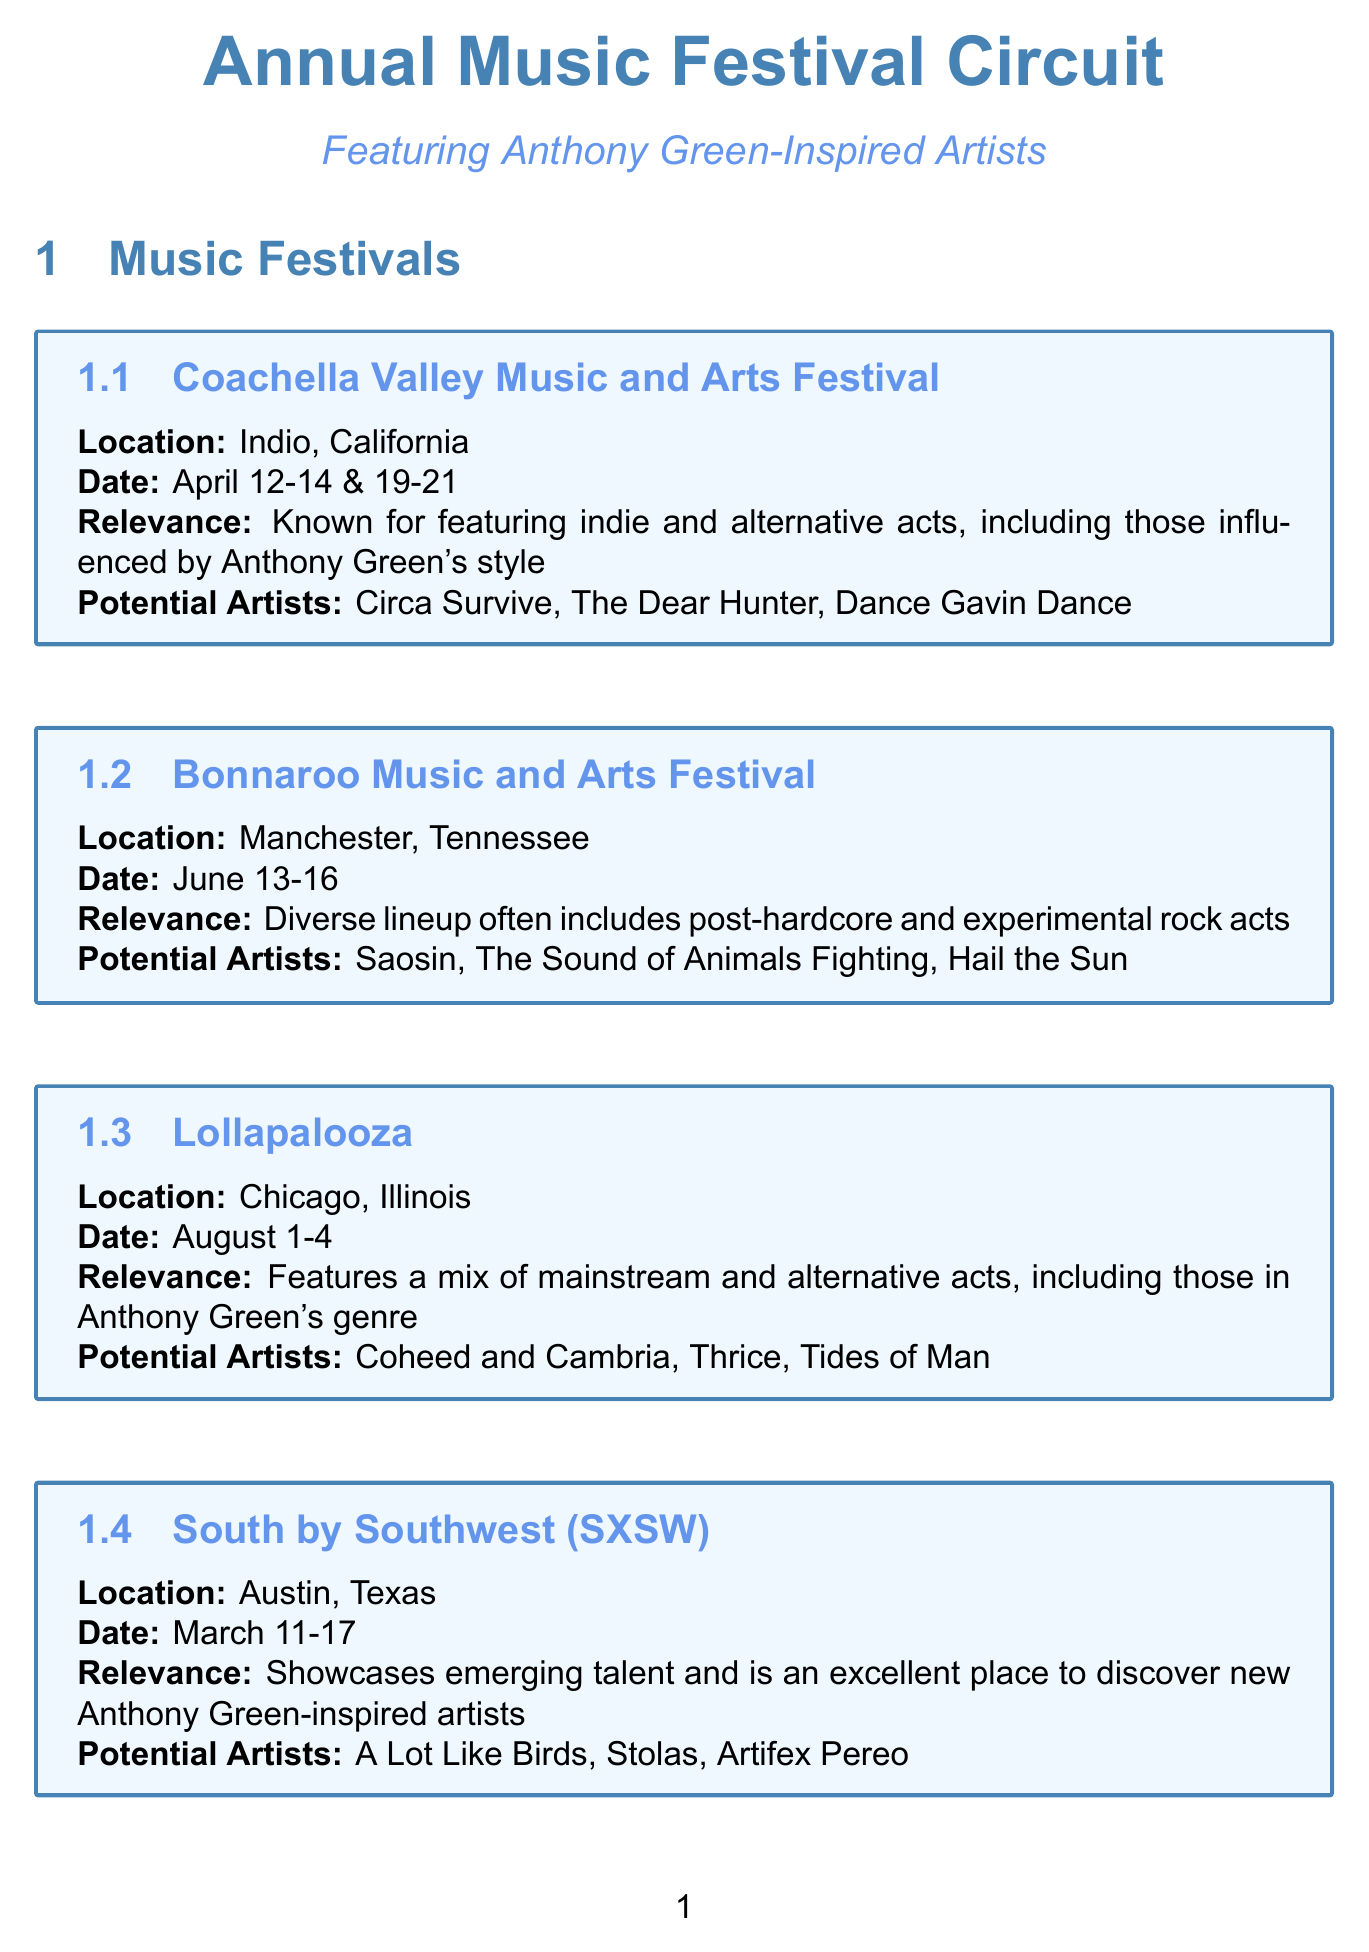What is the location of Coachella Valley Music and Arts Festival? The location is listed in the event details for Coachella Valley Music and Arts Festival.
Answer: Indio, California When does the South by Southwest (SXSW) event take place? The date is specifically mentioned in the schedule for South by Southwest (SXSW).
Answer: March 11-17 Which festival has potential artists including 'Chiodos'? The festival is indicated along with its corresponding potential artists.
Answer: Riot Fest What type of acts is featured at Bonnaroo Music and Arts Festival? The relevance section describes the types of acts that are often featured at this festival.
Answer: Post-hardcore and experimental rock acts How many days does the Lollapalooza festival last? The duration can be deduced from the date range provided in the Lollapalooza section.
Answer: 4 days Which industry event occurs in January? The month of the event is specified in the schedule for NAMM Show.
Answer: NAMM Show What is the relevance of the Equal Vision Records Showcase? The relevance is explained in the context of the event and its focus.
Answer: Known for signing post-hardcore and experimental rock acts In which city is Fearless Records' Punk Rock Showcase held? The location is specified in the event's details.
Answer: Los Angeles, California What is the date of Furnace Fest? The date is listed under the Furnace Fest section of the document.
Answer: September 20-22 